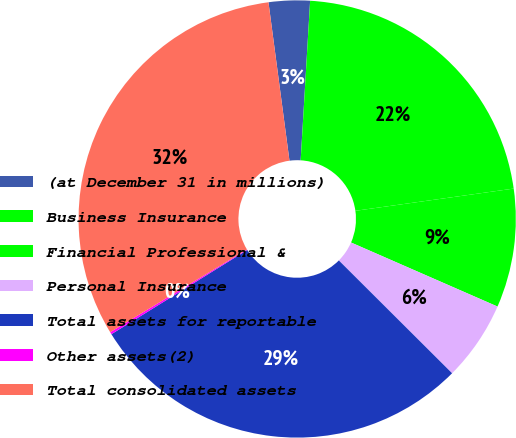<chart> <loc_0><loc_0><loc_500><loc_500><pie_chart><fcel>(at December 31 in millions)<fcel>Business Insurance<fcel>Financial Professional &<fcel>Personal Insurance<fcel>Total assets for reportable<fcel>Other assets(2)<fcel>Total consolidated assets<nl><fcel>3.04%<fcel>21.84%<fcel>8.78%<fcel>5.91%<fcel>28.7%<fcel>0.17%<fcel>31.57%<nl></chart> 